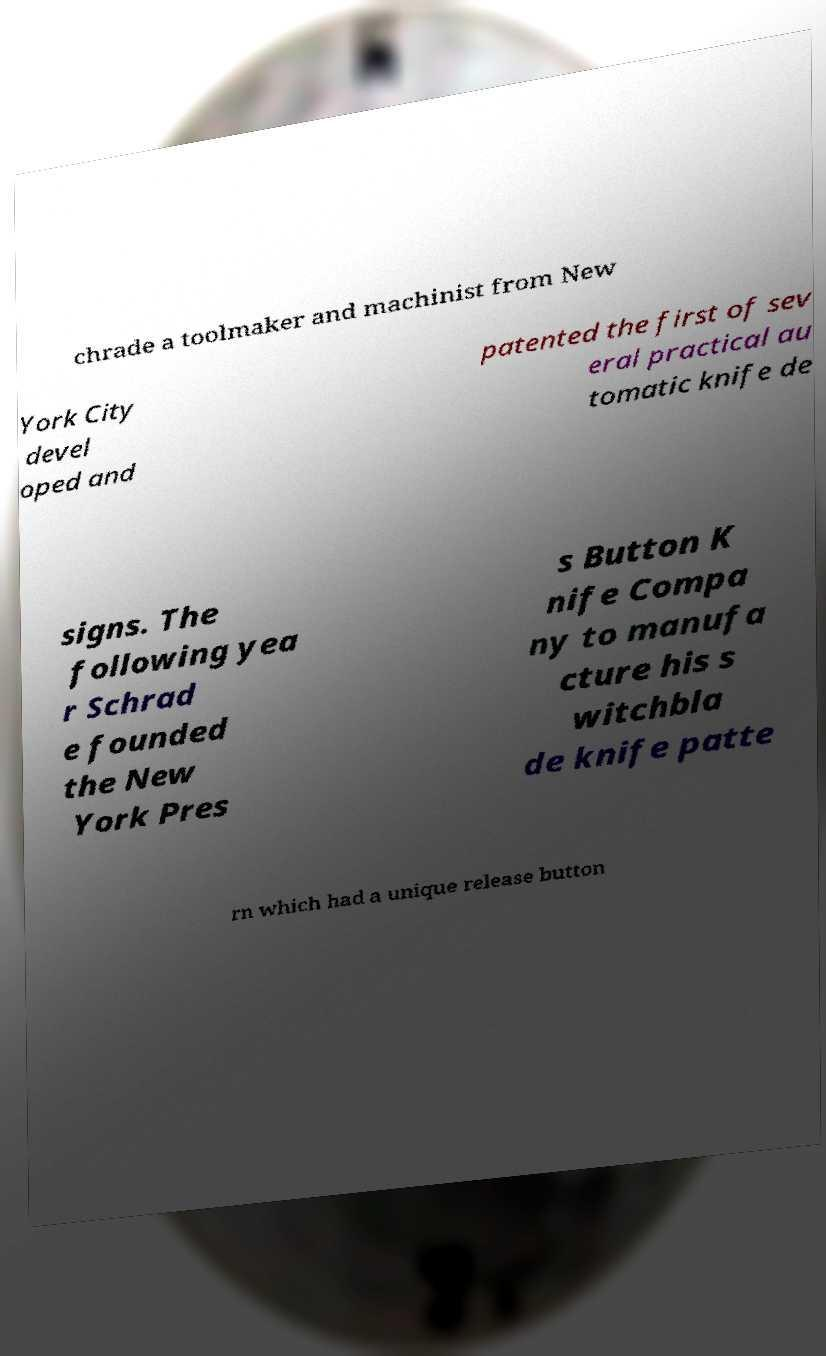Could you assist in decoding the text presented in this image and type it out clearly? chrade a toolmaker and machinist from New York City devel oped and patented the first of sev eral practical au tomatic knife de signs. The following yea r Schrad e founded the New York Pres s Button K nife Compa ny to manufa cture his s witchbla de knife patte rn which had a unique release button 